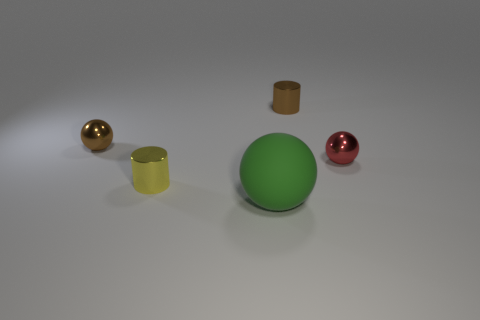Is there anything else that is the same material as the red object?
Ensure brevity in your answer.  Yes. What shape is the large matte object?
Your response must be concise. Sphere. There is a matte thing that is right of the small brown metal object that is in front of the small cylinder that is behind the red shiny object; how big is it?
Offer a terse response. Large. What number of other objects are there of the same shape as the yellow metal thing?
Offer a very short reply. 1. There is a object in front of the yellow cylinder; does it have the same shape as the tiny thing that is on the left side of the yellow metallic thing?
Ensure brevity in your answer.  Yes. What number of cylinders are either metal objects or yellow objects?
Provide a short and direct response. 2. There is a ball in front of the shiny sphere that is to the right of the small brown thing that is left of the tiny yellow metal object; what is its material?
Provide a succinct answer. Rubber. What number of other things are the same size as the rubber ball?
Your answer should be compact. 0. Is the number of shiny balls that are on the left side of the tiny yellow shiny cylinder greater than the number of cyan cylinders?
Your answer should be very brief. Yes. What is the color of the other metallic cylinder that is the same size as the yellow cylinder?
Ensure brevity in your answer.  Brown. 